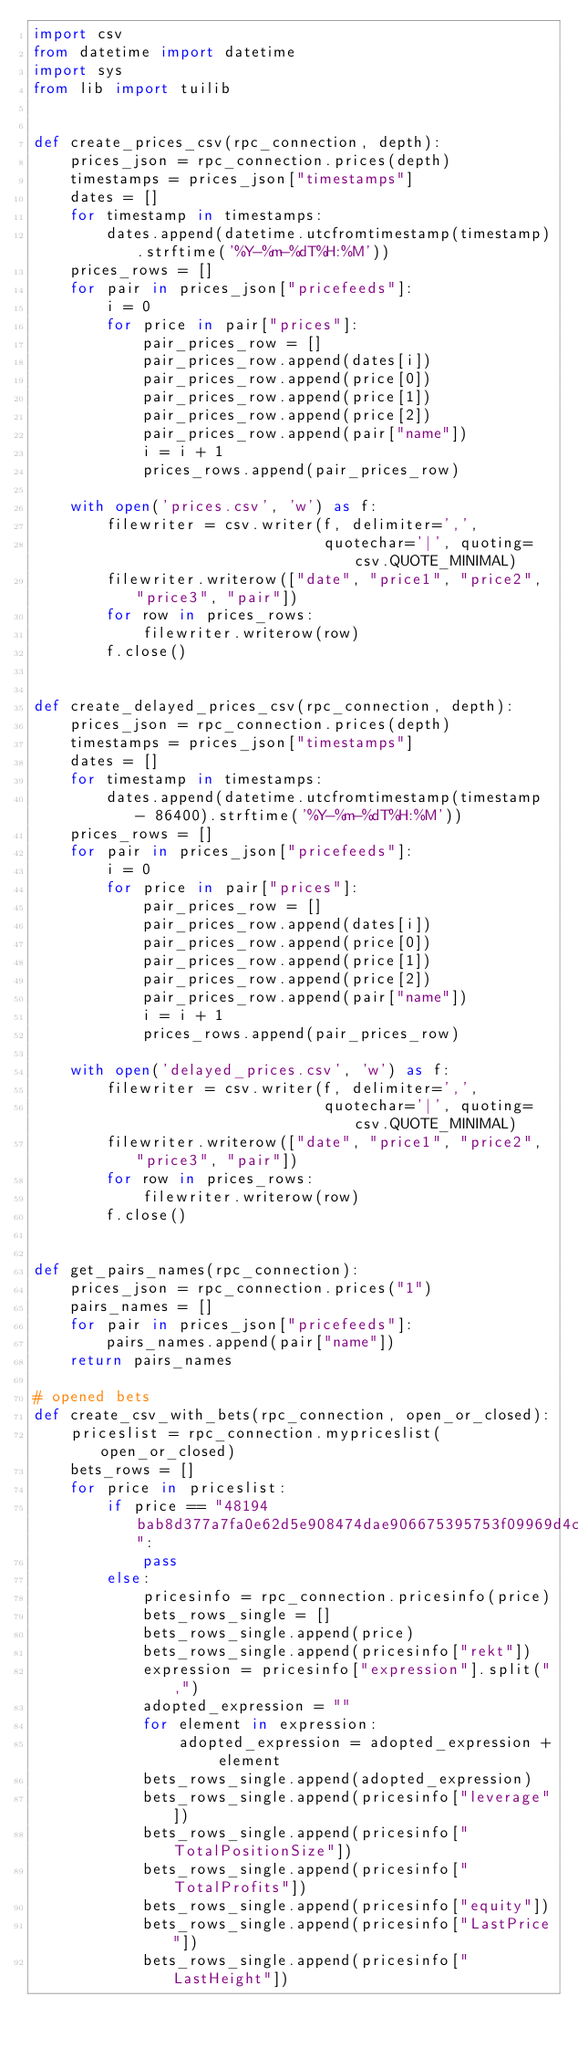<code> <loc_0><loc_0><loc_500><loc_500><_Python_>import csv
from datetime import datetime
import sys
from lib import tuilib


def create_prices_csv(rpc_connection, depth):
    prices_json = rpc_connection.prices(depth)
    timestamps = prices_json["timestamps"]
    dates = []
    for timestamp in timestamps:
        dates.append(datetime.utcfromtimestamp(timestamp).strftime('%Y-%m-%dT%H:%M'))
    prices_rows = []
    for pair in prices_json["pricefeeds"]:
        i = 0
        for price in pair["prices"]:
            pair_prices_row = []
            pair_prices_row.append(dates[i])
            pair_prices_row.append(price[0])
            pair_prices_row.append(price[1])
            pair_prices_row.append(price[2])
            pair_prices_row.append(pair["name"])
            i = i + 1
            prices_rows.append(pair_prices_row)

    with open('prices.csv', 'w') as f:
        filewriter = csv.writer(f, delimiter=',',
                                quotechar='|', quoting=csv.QUOTE_MINIMAL)
        filewriter.writerow(["date", "price1", "price2", "price3", "pair"])
        for row in prices_rows:
            filewriter.writerow(row)
        f.close()


def create_delayed_prices_csv(rpc_connection, depth):
    prices_json = rpc_connection.prices(depth)
    timestamps = prices_json["timestamps"]
    dates = []
    for timestamp in timestamps:
        dates.append(datetime.utcfromtimestamp(timestamp - 86400).strftime('%Y-%m-%dT%H:%M'))
    prices_rows = []
    for pair in prices_json["pricefeeds"]:
        i = 0
        for price in pair["prices"]:
            pair_prices_row = []
            pair_prices_row.append(dates[i])
            pair_prices_row.append(price[0])
            pair_prices_row.append(price[1])
            pair_prices_row.append(price[2])
            pair_prices_row.append(pair["name"])
            i = i + 1
            prices_rows.append(pair_prices_row)

    with open('delayed_prices.csv', 'w') as f:
        filewriter = csv.writer(f, delimiter=',',
                                quotechar='|', quoting=csv.QUOTE_MINIMAL)
        filewriter.writerow(["date", "price1", "price2", "price3", "pair"])
        for row in prices_rows:
            filewriter.writerow(row)
        f.close()


def get_pairs_names(rpc_connection):
    prices_json = rpc_connection.prices("1")
    pairs_names = []
    for pair in prices_json["pricefeeds"]:
        pairs_names.append(pair["name"])
    return pairs_names

# opened bets
def create_csv_with_bets(rpc_connection, open_or_closed):
    priceslist = rpc_connection.mypriceslist(open_or_closed)
    bets_rows = []
    for price in priceslist:
        if price == "48194bab8d377a7fa0e62d5e908474dae906675395753f09969d4c4bea4a7518":
            pass
        else:
            pricesinfo = rpc_connection.pricesinfo(price)
            bets_rows_single = []
            bets_rows_single.append(price)
            bets_rows_single.append(pricesinfo["rekt"])
            expression = pricesinfo["expression"].split(",")
            adopted_expression = ""
            for element in expression:
                adopted_expression = adopted_expression + element
            bets_rows_single.append(adopted_expression)
            bets_rows_single.append(pricesinfo["leverage"])
            bets_rows_single.append(pricesinfo["TotalPositionSize"])
            bets_rows_single.append(pricesinfo["TotalProfits"])
            bets_rows_single.append(pricesinfo["equity"])
            bets_rows_single.append(pricesinfo["LastPrice"])
            bets_rows_single.append(pricesinfo["LastHeight"])</code> 